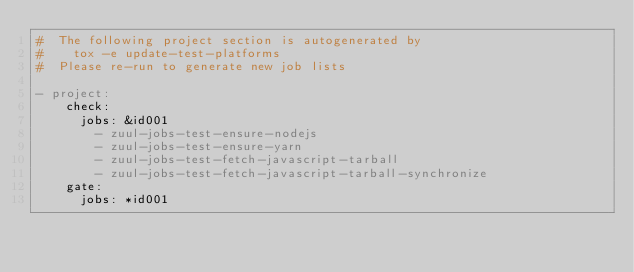Convert code to text. <code><loc_0><loc_0><loc_500><loc_500><_YAML_>#  The following project section is autogenerated by
#    tox -e update-test-platforms
#  Please re-run to generate new job lists

- project:
    check:
      jobs: &id001
        - zuul-jobs-test-ensure-nodejs
        - zuul-jobs-test-ensure-yarn
        - zuul-jobs-test-fetch-javascript-tarball
        - zuul-jobs-test-fetch-javascript-tarball-synchronize
    gate:
      jobs: *id001
</code> 